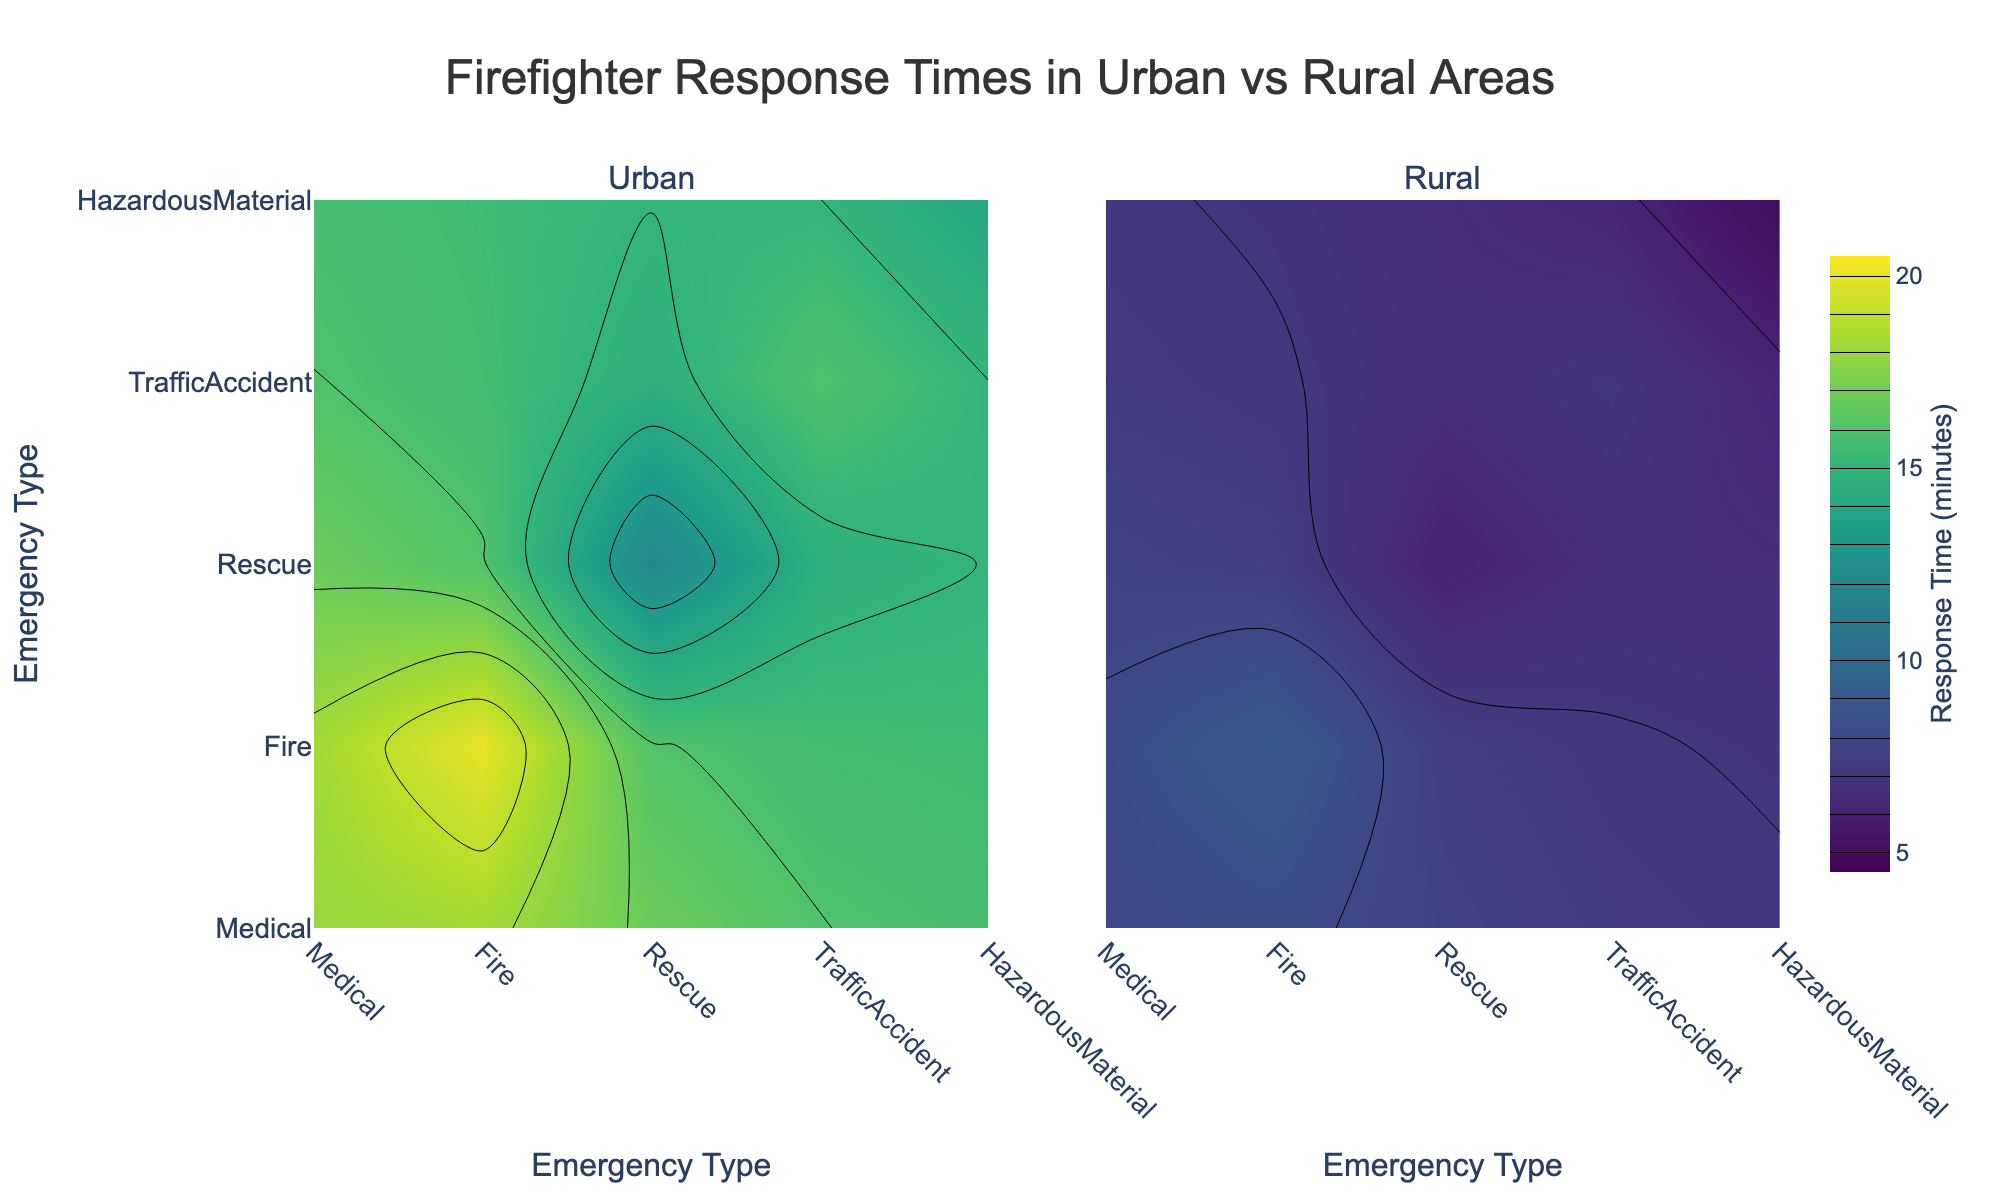What's the average response time for Medical emergencies in Urban areas? Look at the Urban contour plot and locate the value corresponding to Medical emergencies. The value is 6 minutes.
Answer: 6 minutes Compare the response time for Rescue emergencies between Urban and Rural areas. Which is higher? Observe the values for Rescue emergencies in both Urban and Rural areas. Urban has 7 minutes, and Rural has 16 minutes. The response time is higher in Rural areas.
Answer: Rural What is the range of response times for Hazardous Material emergencies in Rural areas? Examine the Rural contour plot and check the values for Hazardous Material emergencies, noting the minimum and maximum response times, which are 15 and 30 minutes, respectively.
Answer: 15 to 30 minutes Which type of emergency has the shortest response time in Urban areas? Look at all the values in the Urban contour plot. The shortest response time is 5 minutes for Traffic Accidents.
Answer: Traffic Accidents Are there any emergency types where the response time is the same in both Urban and Rural areas? Compare the values for each emergency type between Urban and Rural areas. There are no emergencies with the same response times in both areas.
Answer: No What is the difference in response time for Fire emergencies between Urban and Rural areas? Identify the response time for Fire emergencies in Urban (8 minutes) and Rural (18 minutes). The difference is 18 - 8 = 10 minutes.
Answer: 10 minutes How do response times for Traffic Accidents in Rural areas compare to Medical emergencies in Urban areas? For Rural areas, the response time for Traffic Accidents is 14 minutes. For Urban areas, the Medical emergencies response time is 6 minutes. The response time for Traffic Accidents in Rural areas is higher.
Answer: Higher What are the maximum response times for Medical emergencies in Urban and Rural areas? The max response times for Medical emergencies: In Urban areas, it's 10 minutes; In Rural areas, it's 20 minutes.
Answer: Urban: 10 minutes, Rural: 20 minutes Which area is generally quicker in responding to emergencies, considering all types of emergencies? Compare overall response times in both Urban and Rural areas. Urban areas generally have lower response times across all emergency types compared to Rural areas.
Answer: Urban Calculate the average response time for all emergency types combined in Urban areas. Sum the response times for all emergencies in Urban areas (6 + 8 + 7 + 5 + 9 = 35 minutes), then divide by the number of types (5). 35 / 5 = 7 minutes.
Answer: 7 minutes 